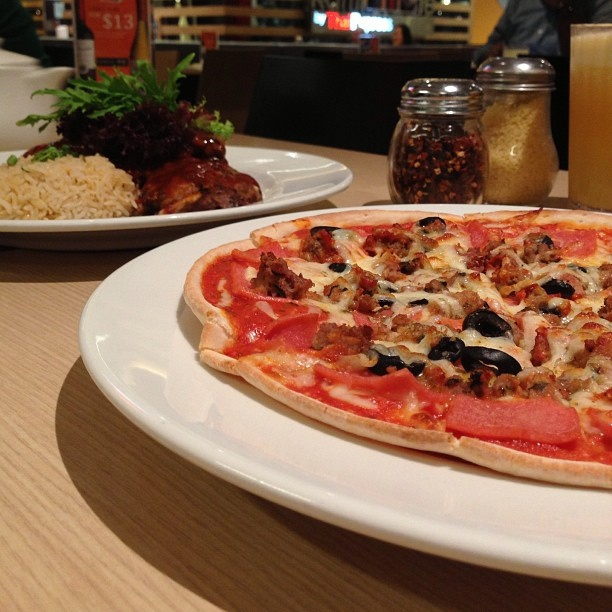Describe the objects in this image and their specific colors. I can see dining table in black, tan, maroon, and lightgray tones, pizza in black, tan, brown, and maroon tones, and cup in black, brown, maroon, and olive tones in this image. 